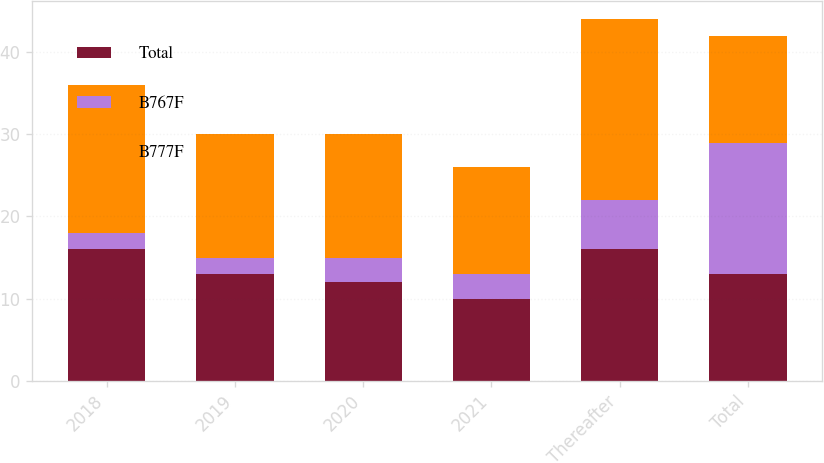Convert chart. <chart><loc_0><loc_0><loc_500><loc_500><stacked_bar_chart><ecel><fcel>2018<fcel>2019<fcel>2020<fcel>2021<fcel>Thereafter<fcel>Total<nl><fcel>Total<fcel>16<fcel>13<fcel>12<fcel>10<fcel>16<fcel>13<nl><fcel>B767F<fcel>2<fcel>2<fcel>3<fcel>3<fcel>6<fcel>16<nl><fcel>B777F<fcel>18<fcel>15<fcel>15<fcel>13<fcel>22<fcel>13<nl></chart> 